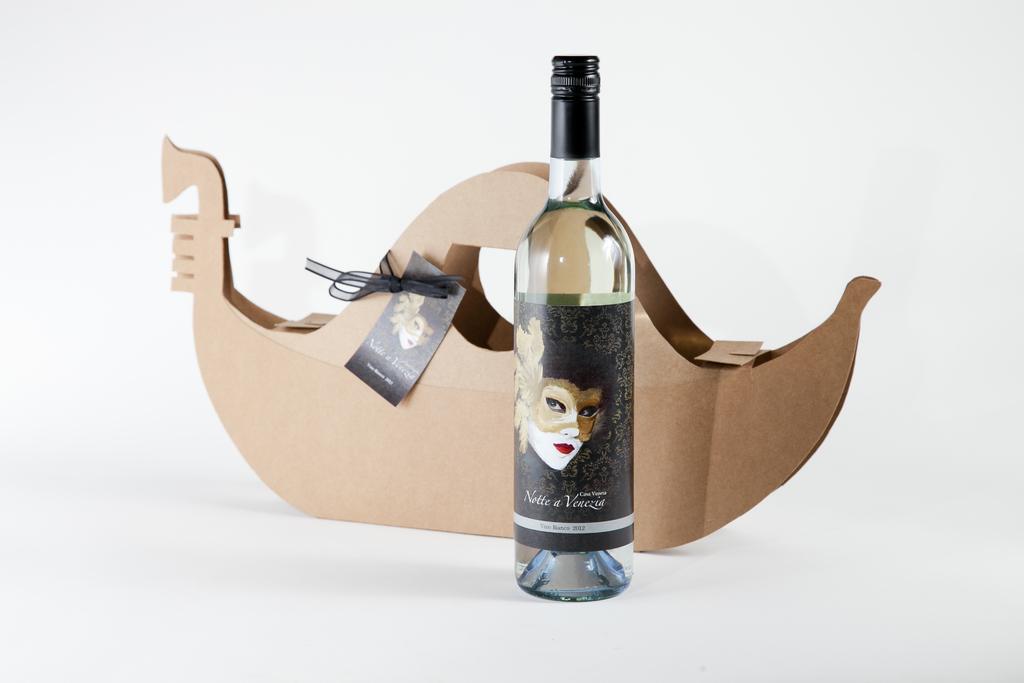What is the name on the bottle?
Ensure brevity in your answer.  Notte a venezia. 